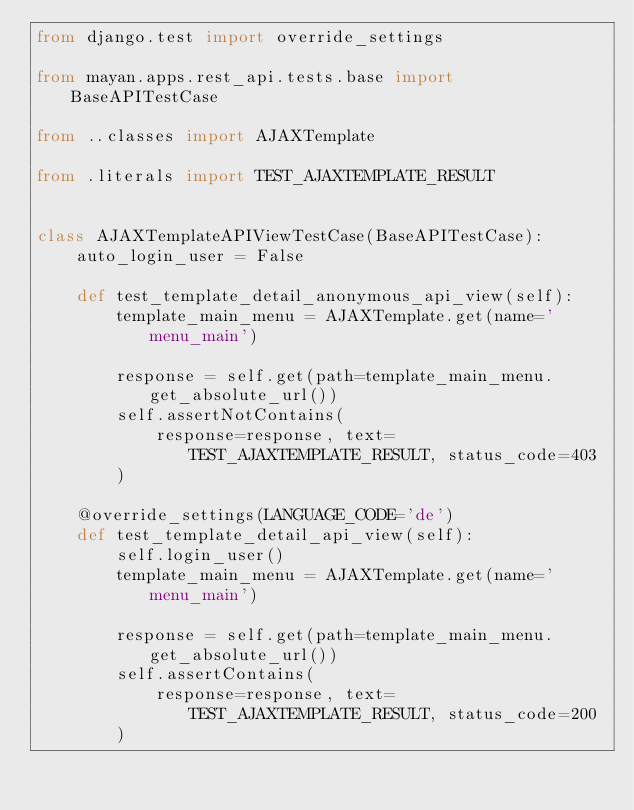<code> <loc_0><loc_0><loc_500><loc_500><_Python_>from django.test import override_settings

from mayan.apps.rest_api.tests.base import BaseAPITestCase

from ..classes import AJAXTemplate

from .literals import TEST_AJAXTEMPLATE_RESULT


class AJAXTemplateAPIViewTestCase(BaseAPITestCase):
    auto_login_user = False

    def test_template_detail_anonymous_api_view(self):
        template_main_menu = AJAXTemplate.get(name='menu_main')

        response = self.get(path=template_main_menu.get_absolute_url())
        self.assertNotContains(
            response=response, text=TEST_AJAXTEMPLATE_RESULT, status_code=403
        )

    @override_settings(LANGUAGE_CODE='de')
    def test_template_detail_api_view(self):
        self.login_user()
        template_main_menu = AJAXTemplate.get(name='menu_main')

        response = self.get(path=template_main_menu.get_absolute_url())
        self.assertContains(
            response=response, text=TEST_AJAXTEMPLATE_RESULT, status_code=200
        )
</code> 